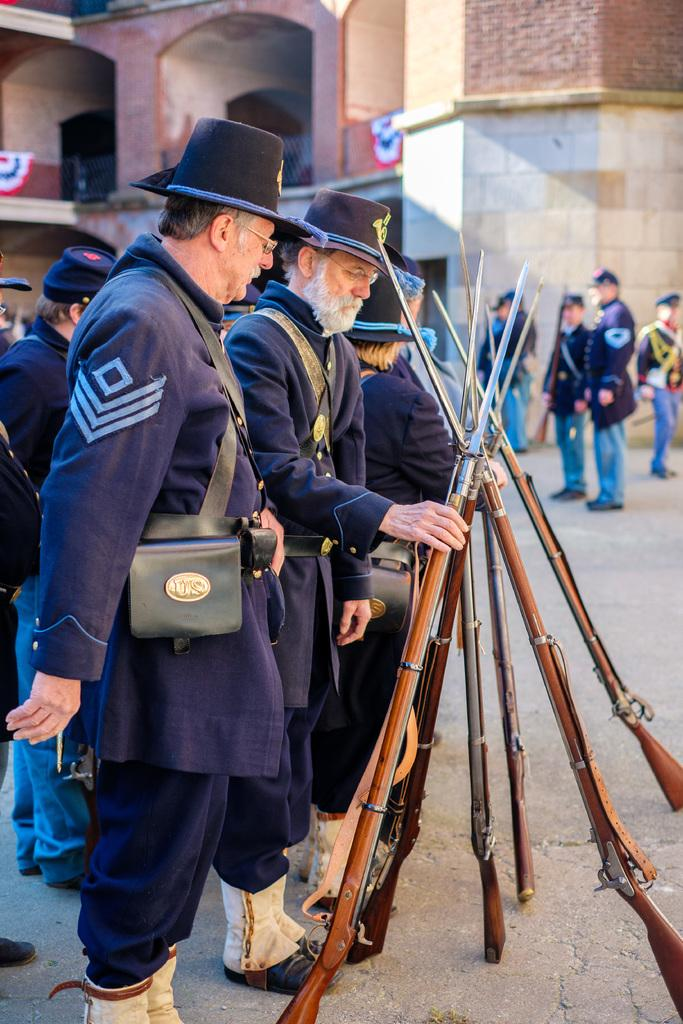What are the people in the image doing? The people in the image are standing and holding guns. What can be seen in the background of the image? There is a building in the background of the image. Are there any other people visible in the image? Yes, there are people standing in front of the building. What type of park can be seen in the image? There is no park present in the image. What kind of apparel are the people wearing in the image? The provided facts do not mention the apparel of the people in the image. 